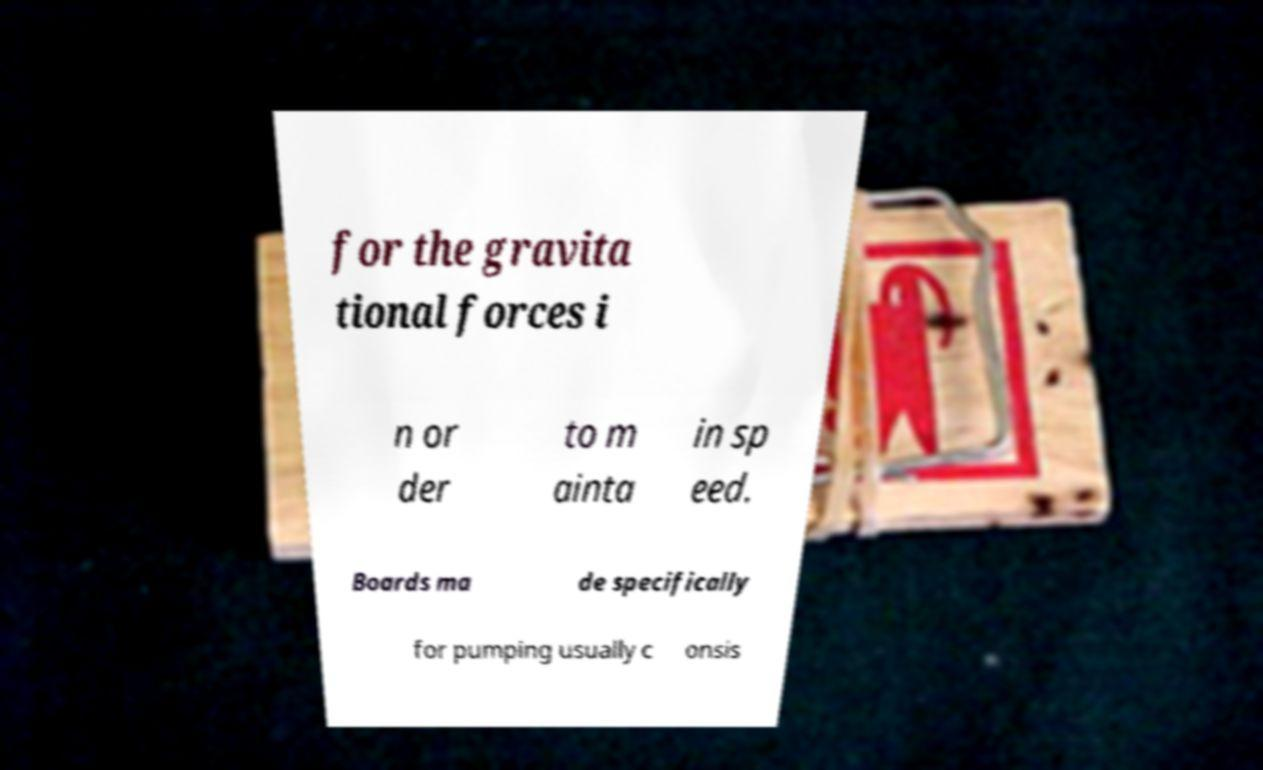There's text embedded in this image that I need extracted. Can you transcribe it verbatim? for the gravita tional forces i n or der to m ainta in sp eed. Boards ma de specifically for pumping usually c onsis 